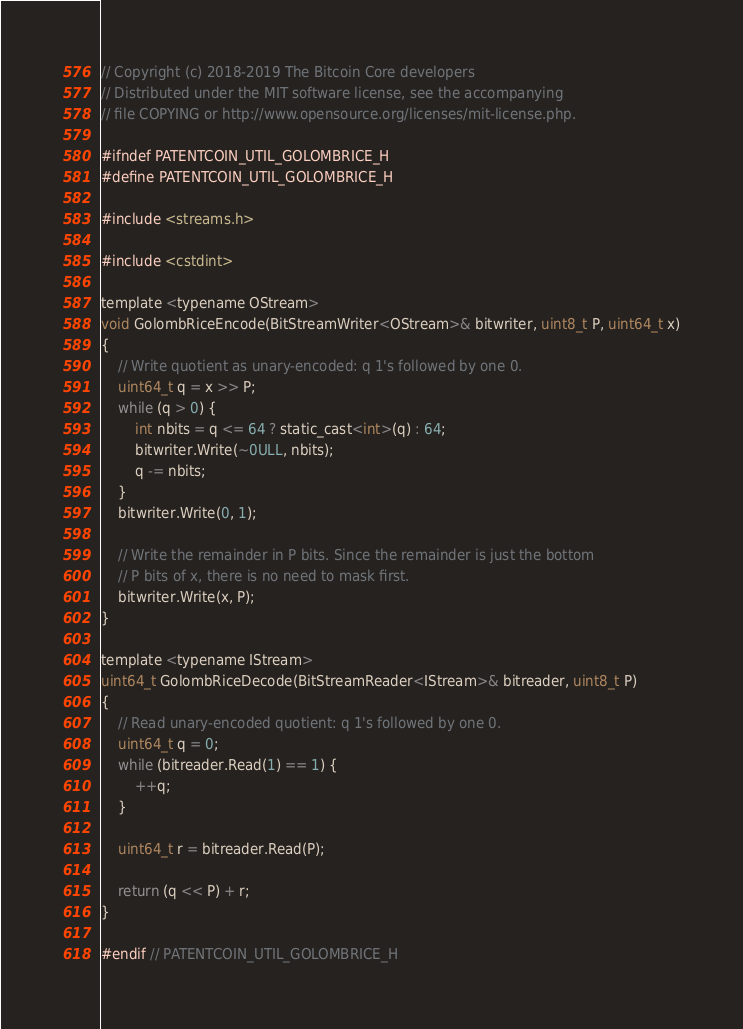<code> <loc_0><loc_0><loc_500><loc_500><_C_>// Copyright (c) 2018-2019 The Bitcoin Core developers
// Distributed under the MIT software license, see the accompanying
// file COPYING or http://www.opensource.org/licenses/mit-license.php.

#ifndef PATENTCOIN_UTIL_GOLOMBRICE_H
#define PATENTCOIN_UTIL_GOLOMBRICE_H

#include <streams.h>

#include <cstdint>

template <typename OStream>
void GolombRiceEncode(BitStreamWriter<OStream>& bitwriter, uint8_t P, uint64_t x)
{
    // Write quotient as unary-encoded: q 1's followed by one 0.
    uint64_t q = x >> P;
    while (q > 0) {
        int nbits = q <= 64 ? static_cast<int>(q) : 64;
        bitwriter.Write(~0ULL, nbits);
        q -= nbits;
    }
    bitwriter.Write(0, 1);

    // Write the remainder in P bits. Since the remainder is just the bottom
    // P bits of x, there is no need to mask first.
    bitwriter.Write(x, P);
}

template <typename IStream>
uint64_t GolombRiceDecode(BitStreamReader<IStream>& bitreader, uint8_t P)
{
    // Read unary-encoded quotient: q 1's followed by one 0.
    uint64_t q = 0;
    while (bitreader.Read(1) == 1) {
        ++q;
    }

    uint64_t r = bitreader.Read(P);

    return (q << P) + r;
}

#endif // PATENTCOIN_UTIL_GOLOMBRICE_H
</code> 